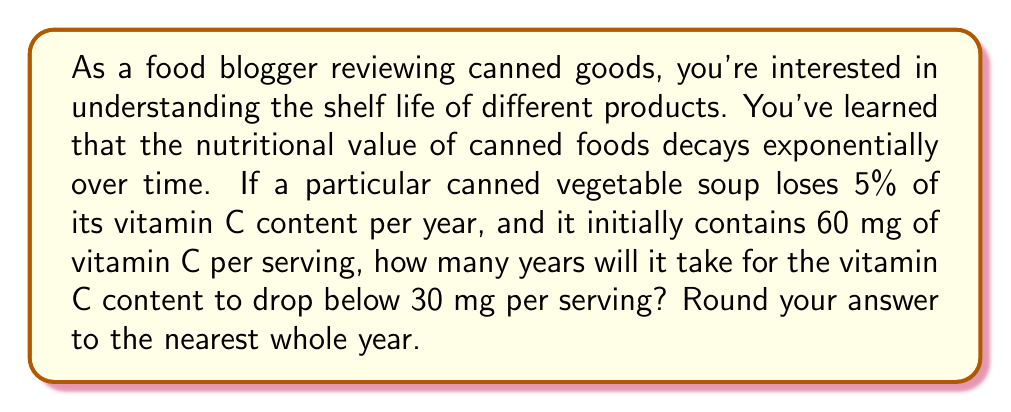Solve this math problem. Let's approach this problem using an exponential decay model:

1) The general form of exponential decay is:

   $$A(t) = A_0 \cdot (1-r)^t$$

   Where:
   $A(t)$ is the amount at time $t$
   $A_0$ is the initial amount
   $r$ is the decay rate per unit time
   $t$ is the time

2) In this case:
   $A_0 = 60$ mg (initial vitamin C content)
   $r = 0.05$ (5% decay per year)
   We want to find $t$ when $A(t) < 30$ mg

3) Let's set up the equation:

   $$30 = 60 \cdot (1-0.05)^t$$

4) Simplify:

   $$30 = 60 \cdot (0.95)^t$$

5) Divide both sides by 60:

   $$0.5 = (0.95)^t$$

6) Take the natural log of both sides:

   $$\ln(0.5) = t \cdot \ln(0.95)$$

7) Solve for $t$:

   $$t = \frac{\ln(0.5)}{\ln(0.95)} \approx 13.51$$

8) Rounding to the nearest whole year:

   $t = 14$ years

Therefore, it will take approximately 14 years for the vitamin C content to drop below 30 mg per serving.
Answer: 14 years 